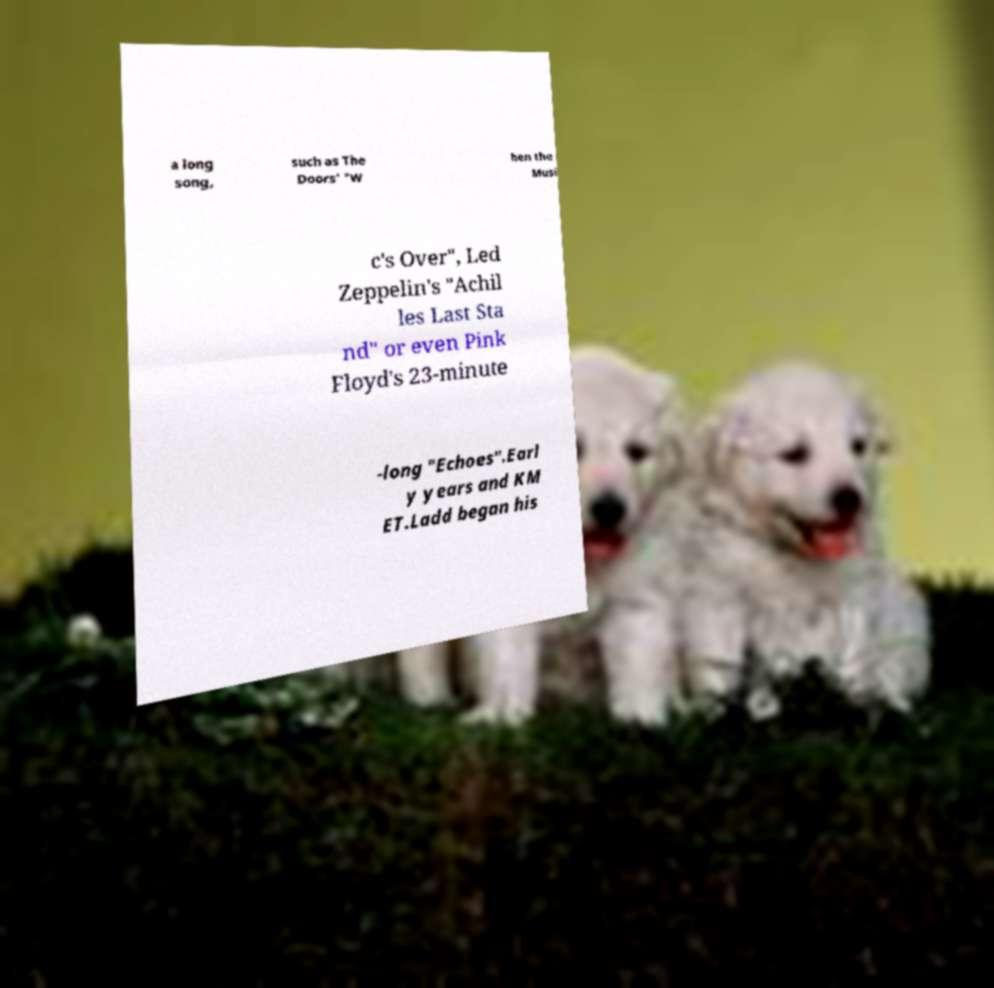Can you read and provide the text displayed in the image?This photo seems to have some interesting text. Can you extract and type it out for me? a long song, such as The Doors' "W hen the Musi c's Over", Led Zeppelin's "Achil les Last Sta nd" or even Pink Floyd's 23-minute -long "Echoes".Earl y years and KM ET.Ladd began his 